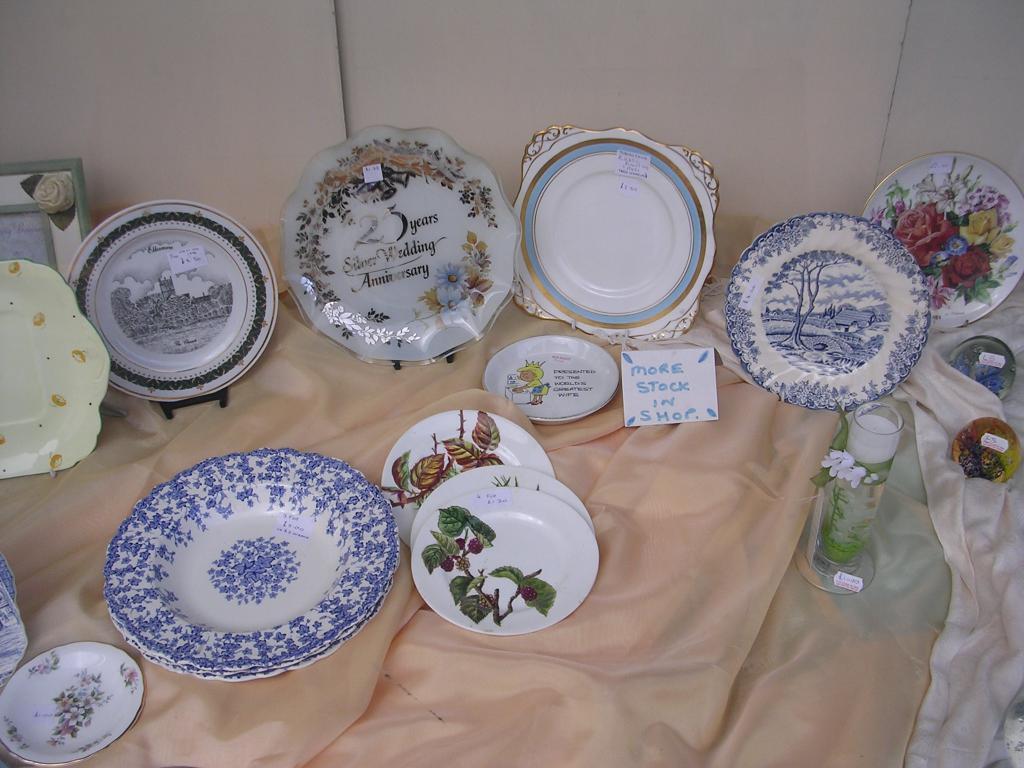Can you describe this image briefly? In this image we can see few plates and glass with design and label on the plates and there is a board with text and a picture frame on the cloth and wall in the background. 